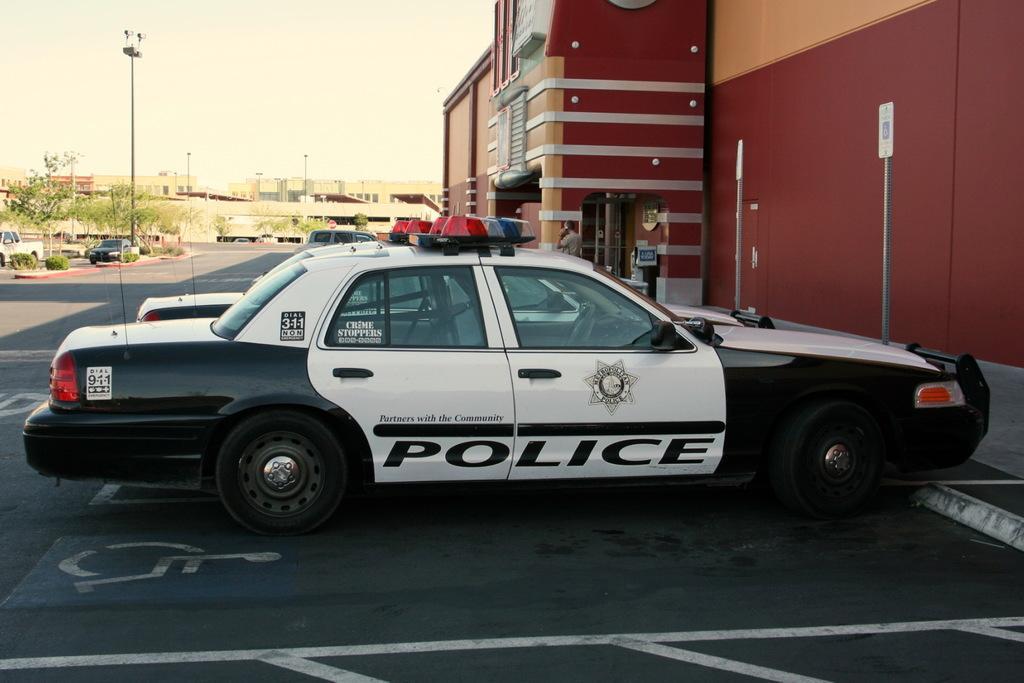Describe this image in one or two sentences. In this picture we can see vehicles on the road, trees, buildings, windows, plants, poles, signboards, some objects and a person standing and in the background we can see the sky. 